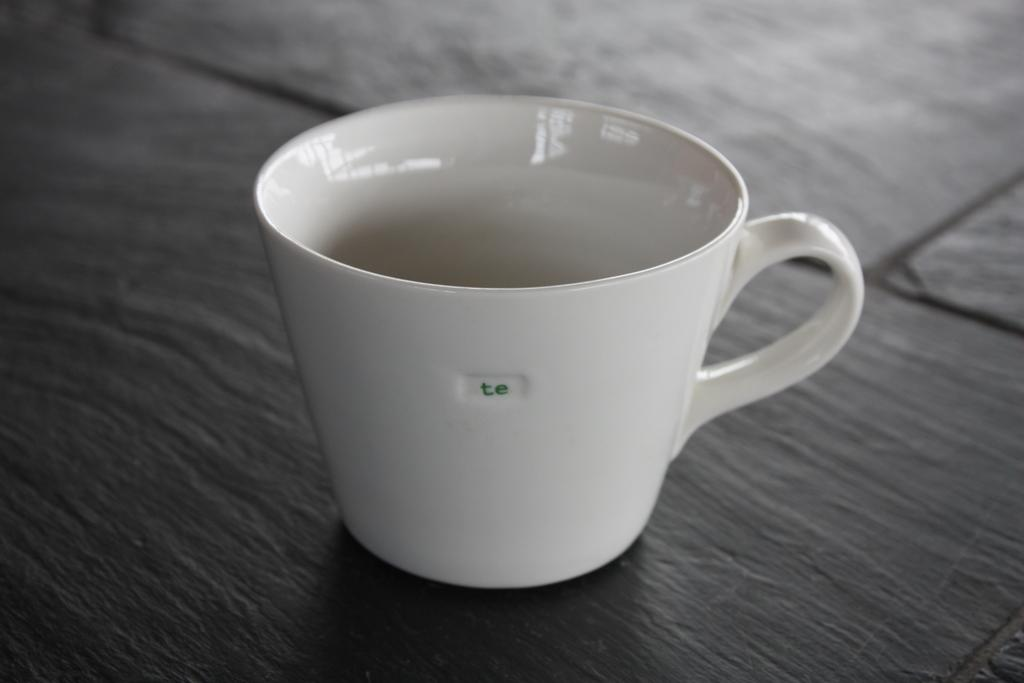<image>
Describe the image concisely. White cup that has the word te wrote on it 